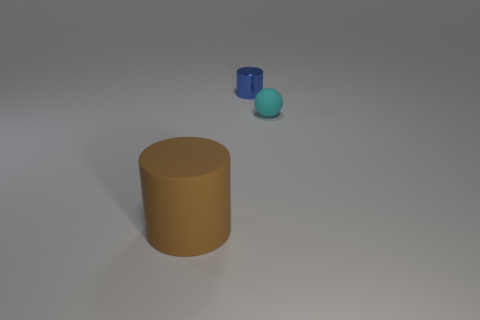Are there any other things that are the same shape as the cyan matte object?
Give a very brief answer. No. Are there any other things that have the same size as the brown cylinder?
Give a very brief answer. No. Is the number of blue objects that are to the right of the big thing greater than the number of red cubes?
Your response must be concise. Yes. There is a cylinder in front of the blue thing; what is it made of?
Keep it short and to the point. Rubber. What number of brown cylinders have the same material as the tiny blue thing?
Provide a short and direct response. 0. What is the shape of the object that is to the left of the tiny cyan object and in front of the small cylinder?
Offer a very short reply. Cylinder. How many things are rubber things that are left of the tiny ball or cylinders that are behind the tiny cyan matte ball?
Your answer should be very brief. 2. Are there an equal number of small cyan rubber spheres that are behind the ball and small blue objects that are on the right side of the large cylinder?
Your answer should be compact. No. There is a thing that is in front of the rubber object right of the big matte thing; what shape is it?
Offer a very short reply. Cylinder. Are there any brown matte objects of the same shape as the tiny blue thing?
Offer a terse response. Yes. 